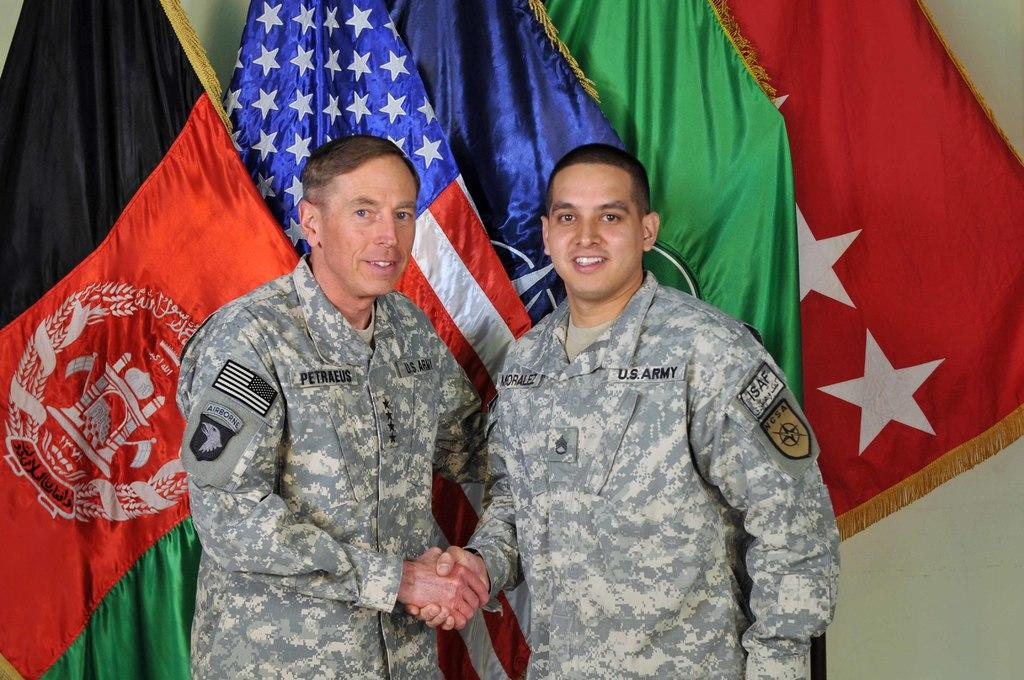How many people are present in the image? There are two people standing in the image. What are the people wearing? The people are wearing military dresses. What can be seen in the background of the image? There are flags in different colors in the background. What color is the wall in the image? The wall is white. How many bikes are leaning against the white wall in the image? There are no bikes present in the image; it features two people wearing military dresses and flags in the background. 